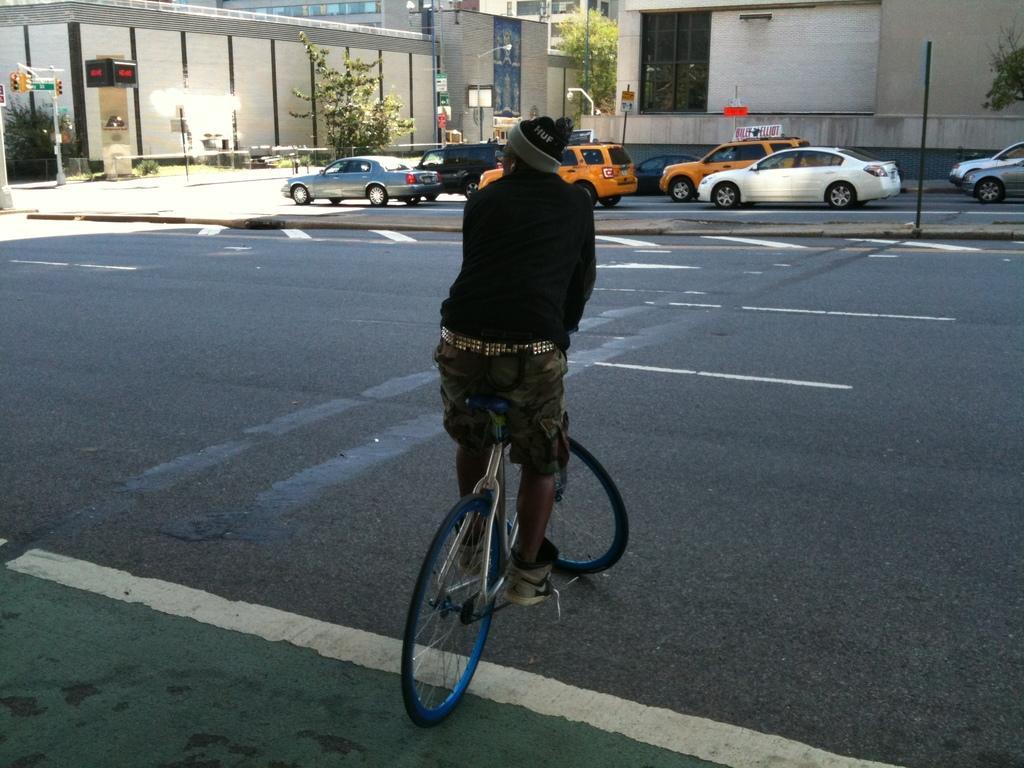Please provide a concise description of this image. In this image I can see a person is on a bicycle. In the background I can see vehicles on roads, poles, traffic lights, trees and buildings. 